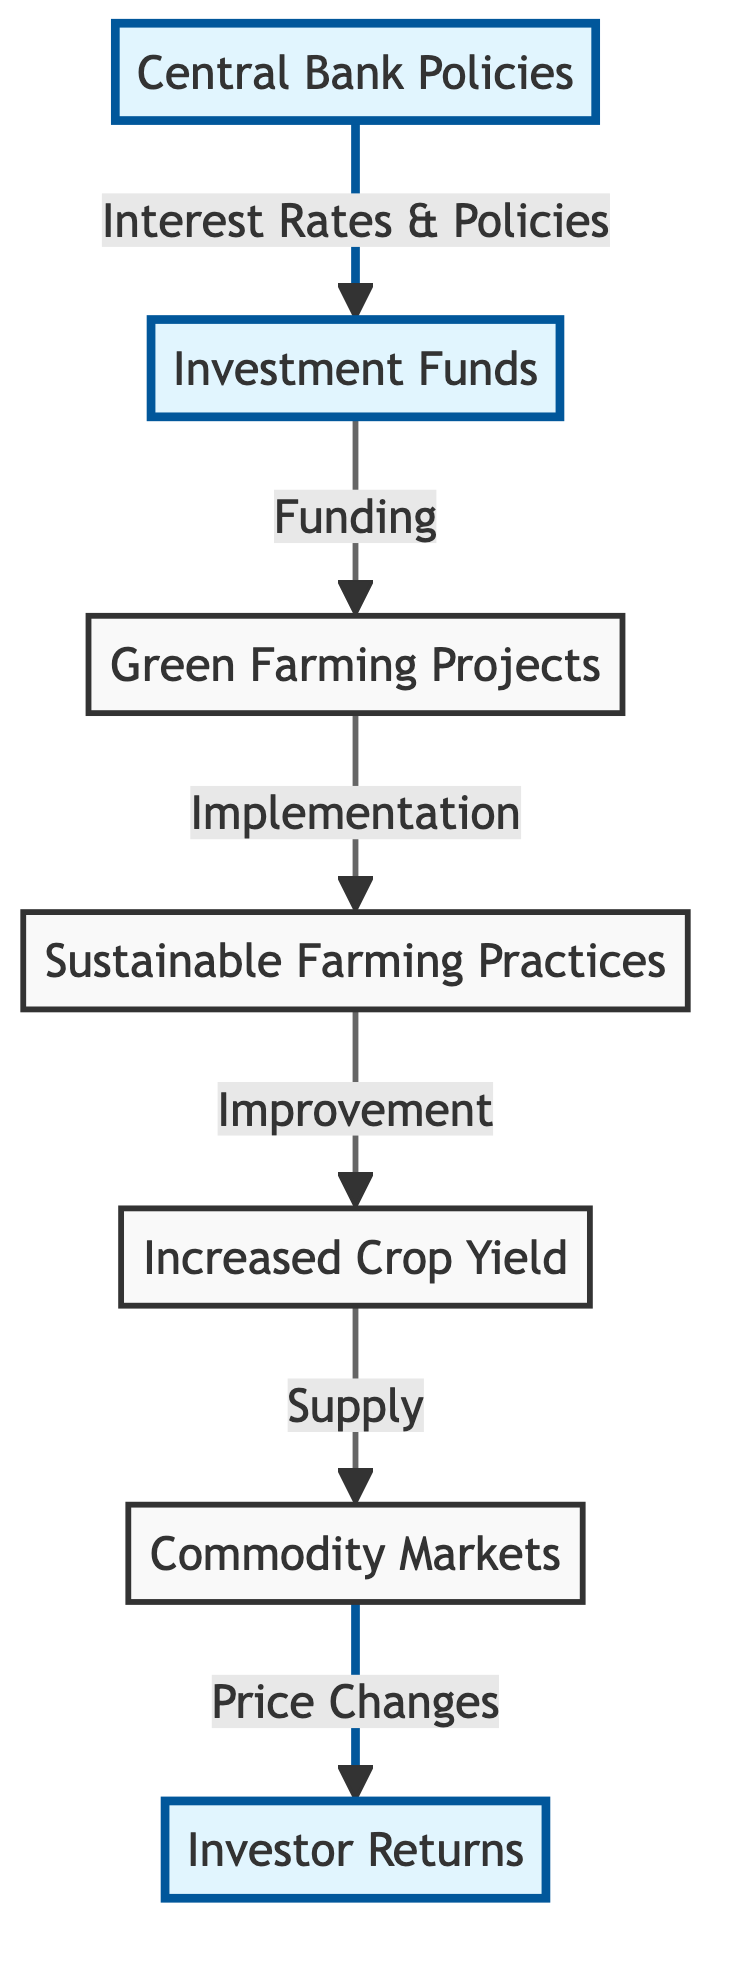What is the starting point of the investment flow? The starting point of the investment flow in the diagram is "Investment Funds," which is the first node. All the other processes are dependent on this initial node.
Answer: Investment Funds Which central bank action influences investment funds? The central bank action that influences investment funds is through "Interest Rates & Policies," which describes the relationship shown in the diagram between Central Bank Policies and Investment Funds.
Answer: Interest Rates & Policies How many total nodes are present in the diagram? Counting all nodes in the diagram, including Investment Funds, Central Bank Policies, and others, there are a total of 7 nodes.
Answer: 7 What is the outcome of sustainable farming practices? The outcome of sustainable farming practices, as seen in the diagram, is represented by "Increased Crop Yield," which directly follows the implementation of sustainable farming practices.
Answer: Increased Crop Yield What follows increased crop yield in the investment flow? Following increased crop yield in the flow is the node "Commodity Markets," where the diagram indicates a supply relationship stemming from yield improvements.
Answer: Commodity Markets What influences investor returns in the diagram? Investor returns are influenced by "Price Changes" within the commodity markets, which are the changes in prices derived from changes in supply due to increased crop yield.
Answer: Price Changes What node connects to sustainable farming practices? The node that connects to sustainable farming practices (D) is "Green Farming Projects" (C), which details the funding process that leads to the implementation of those practices.
Answer: Green Farming Projects What is the final node representing the benefits of the investment flow? The final node indicating the benefits of the entire investment flow, from investment funds down to the outcomes, is "Investor Returns." It summarizes the end benefits realized from earlier stages.
Answer: Investor Returns What is the role of the central bank in this flow? The role of the central bank in this flow is to affect investment funds through policies that ultimately influence sustainable farming investments. This creates a foundational support for the entire flow.
Answer: Affect investment funds through policies 